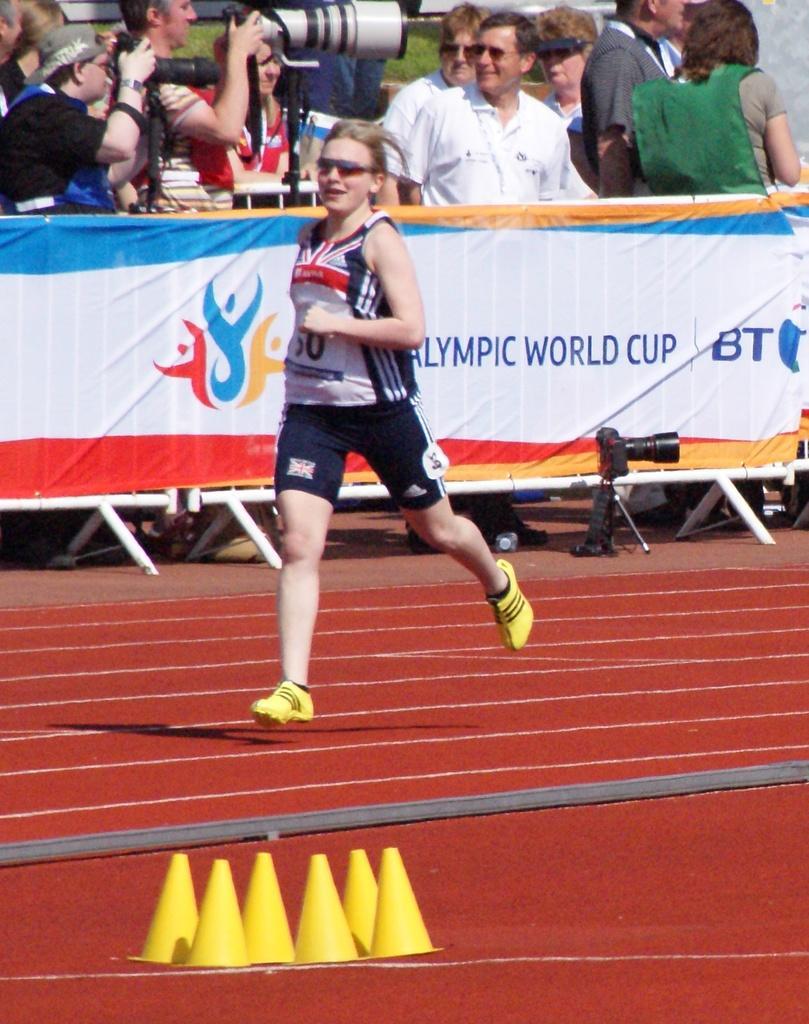Describe this image in one or two sentences. In this image we can see one woman running in a race, one banner attached to the fence, grass on the ground, some poles on the surface, some objects on the surface. Some people are standing and holding some objects. 